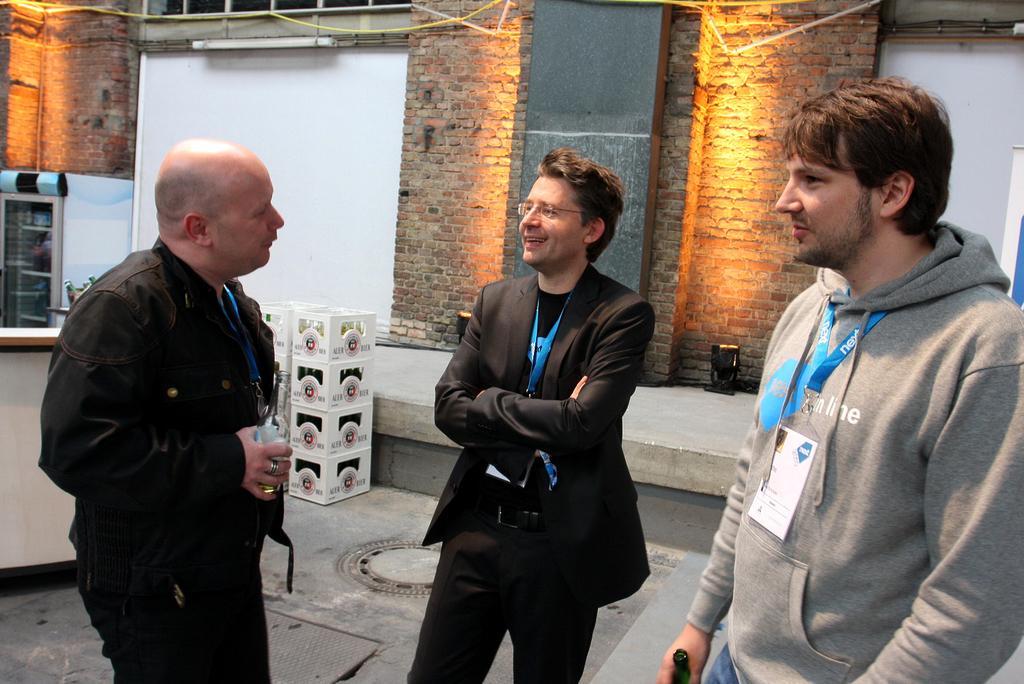How would you summarize this image in a sentence or two? In the image three persons are standing and smiling and holding glass and bottle. Behind them there is wall, on the wall there are some lights and banners. On the left side of the image there is a table. Behind the table there is a refrigerator and boxes. 